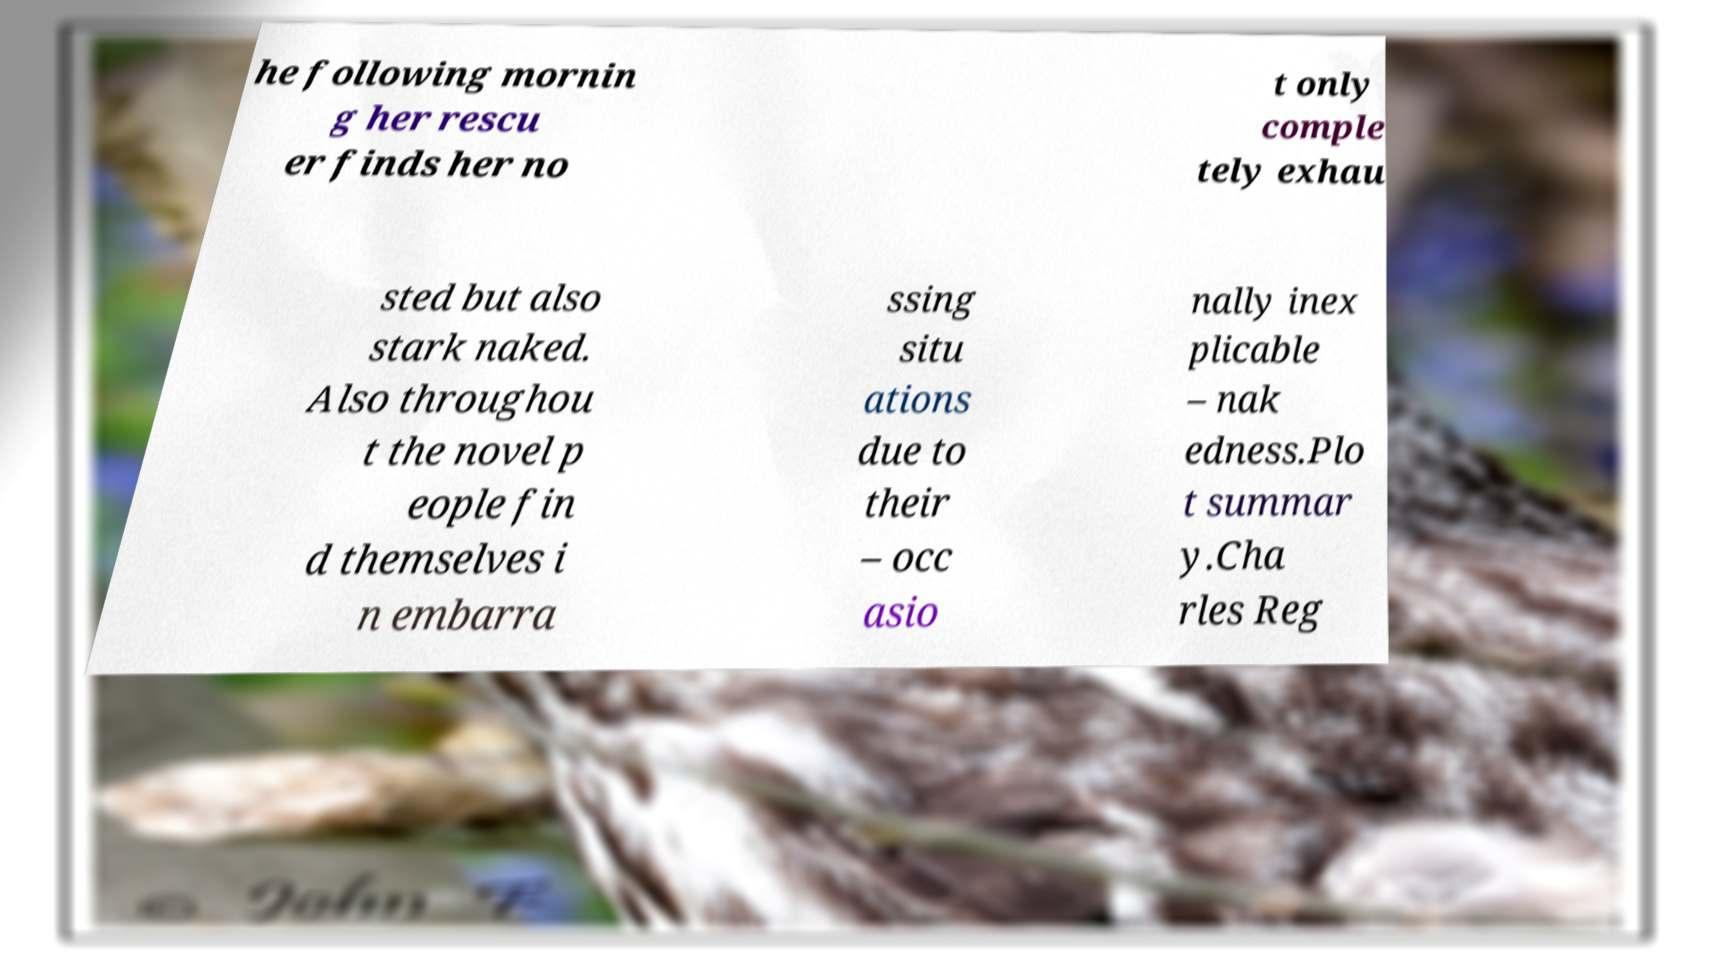Please identify and transcribe the text found in this image. he following mornin g her rescu er finds her no t only comple tely exhau sted but also stark naked. Also throughou t the novel p eople fin d themselves i n embarra ssing situ ations due to their – occ asio nally inex plicable – nak edness.Plo t summar y.Cha rles Reg 